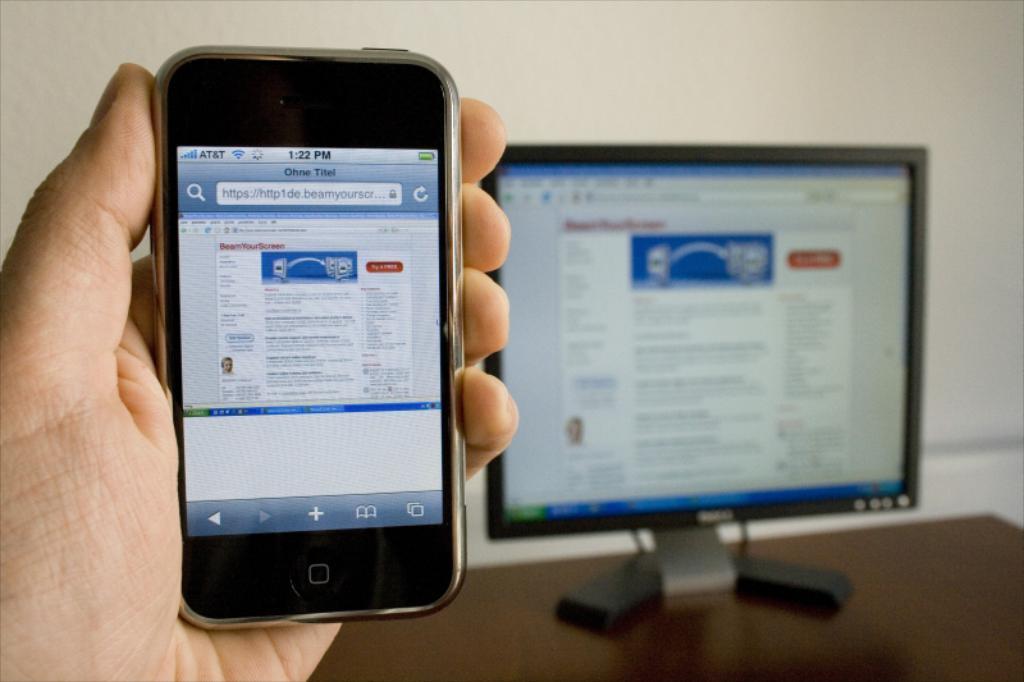Can you describe this image briefly? In this image in the foreground there is one person who is holding a mobile, and in the background there is a computer on the table and wall. 